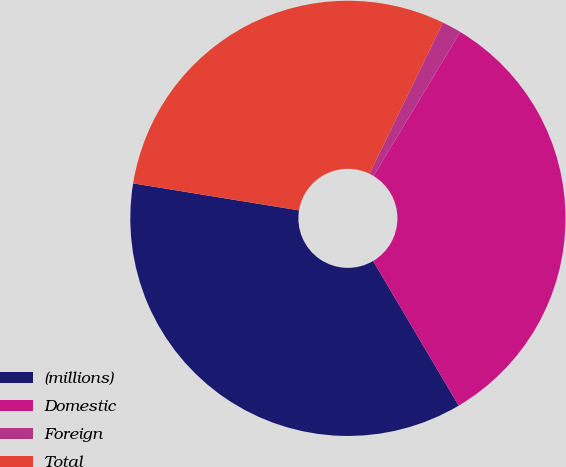Convert chart to OTSL. <chart><loc_0><loc_0><loc_500><loc_500><pie_chart><fcel>(millions)<fcel>Domestic<fcel>Foreign<fcel>Total<nl><fcel>36.07%<fcel>32.85%<fcel>1.45%<fcel>29.62%<nl></chart> 